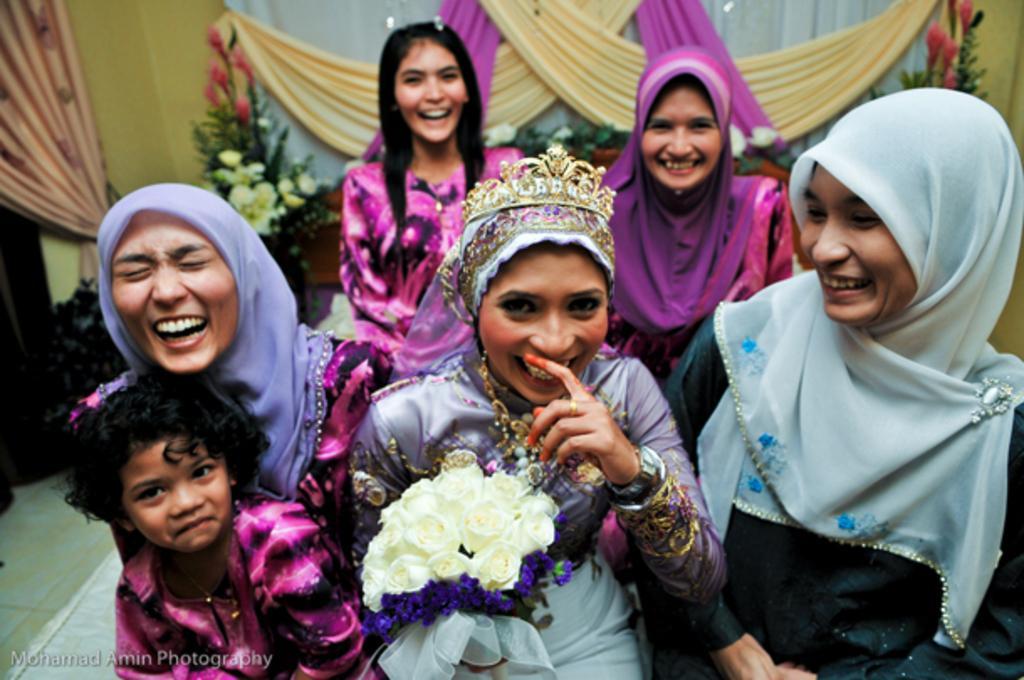How would you summarize this image in a sentence or two? In this image, there are group of people wearing clothes. There is a person in the middle of the image wearing a crown. There are some clothes at the top of the image. 